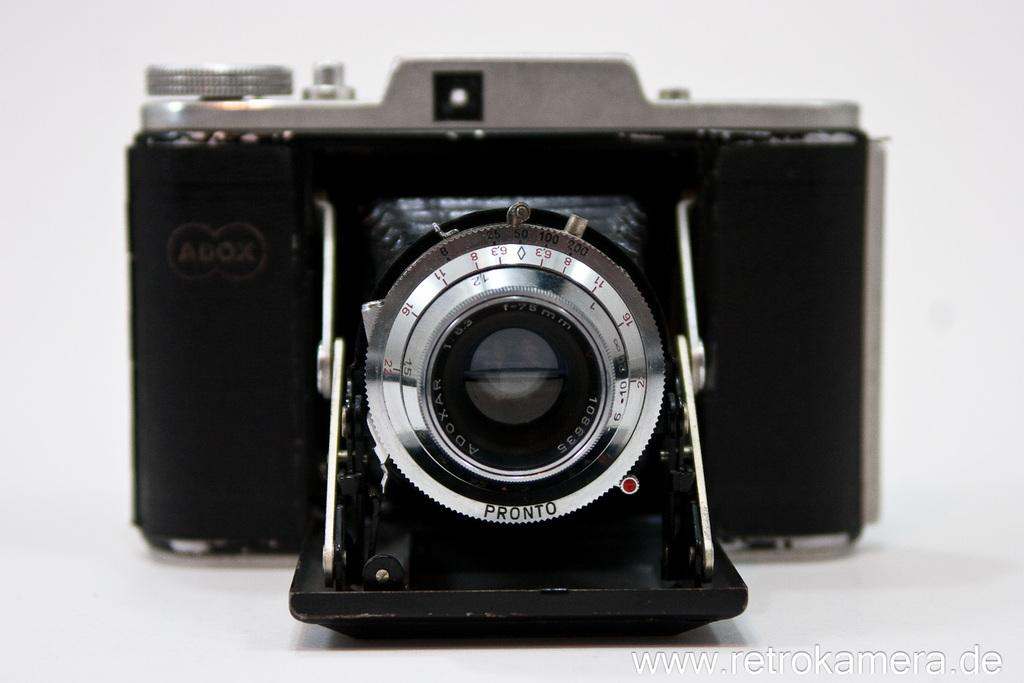What type of camera can be seen in the image? There is an old black color camera in the image. What type of seed is being planted in the crib by the manager in the image? There is no crib, manager, or seed present in the image; it only features an old black color camera. 